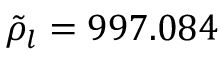Convert formula to latex. <formula><loc_0><loc_0><loc_500><loc_500>\tilde { \rho } _ { l } = 9 9 7 . 0 8 4</formula> 